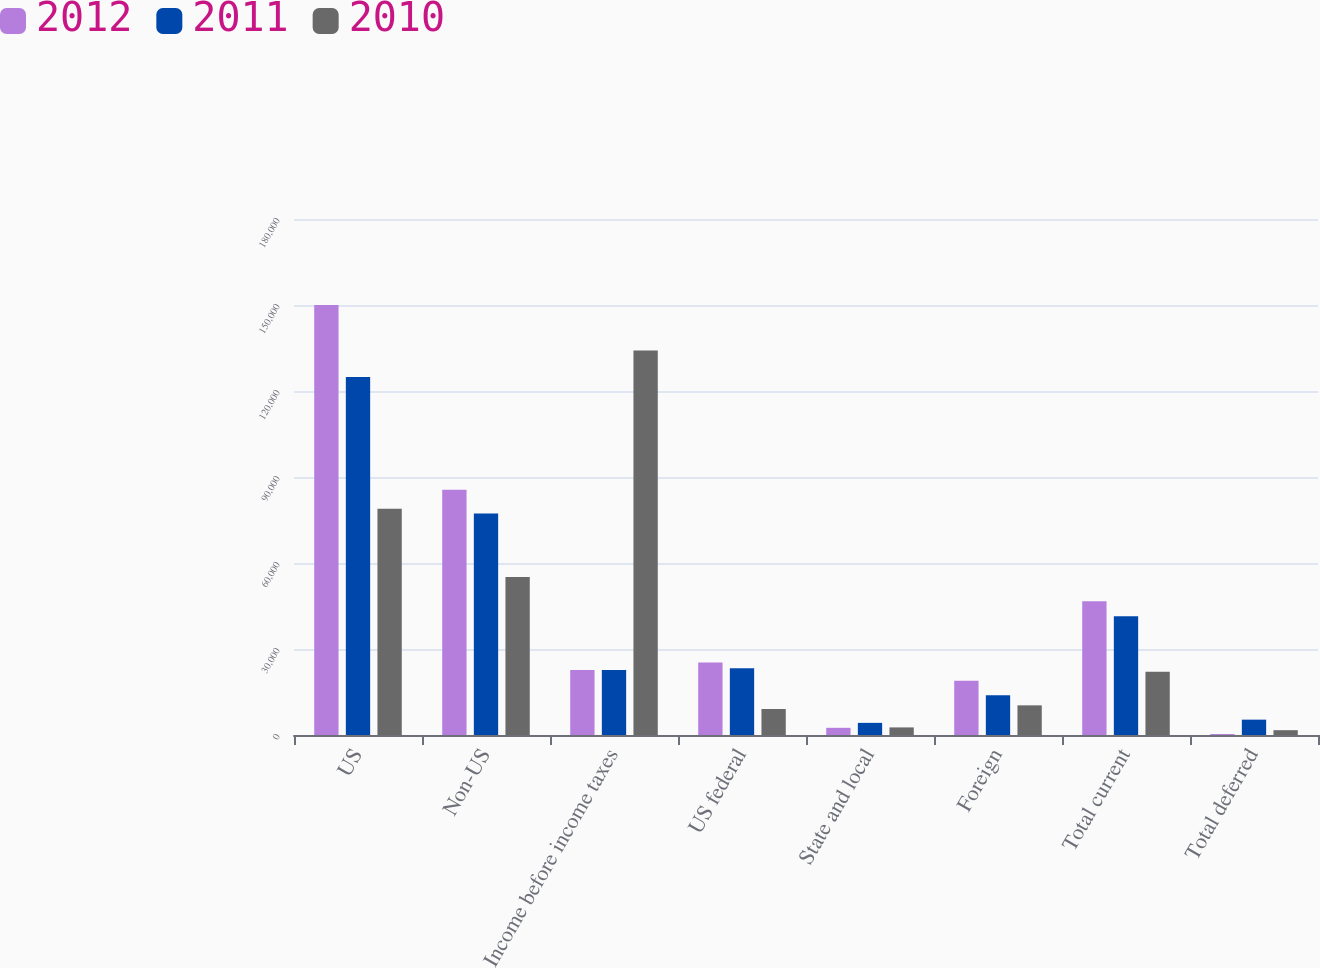<chart> <loc_0><loc_0><loc_500><loc_500><stacked_bar_chart><ecel><fcel>US<fcel>Non-US<fcel>Income before income taxes<fcel>US federal<fcel>State and local<fcel>Foreign<fcel>Total current<fcel>Total deferred<nl><fcel>2012<fcel>150023<fcel>85573<fcel>22695.5<fcel>25290<fcel>2508<fcel>18889<fcel>46687<fcel>339<nl><fcel>2011<fcel>124915<fcel>77269<fcel>22695.5<fcel>23327<fcel>4236<fcel>13845<fcel>41408<fcel>5357<nl><fcel>2010<fcel>78933<fcel>55152<fcel>134085<fcel>9078<fcel>2645<fcel>10341<fcel>22064<fcel>1678<nl></chart> 